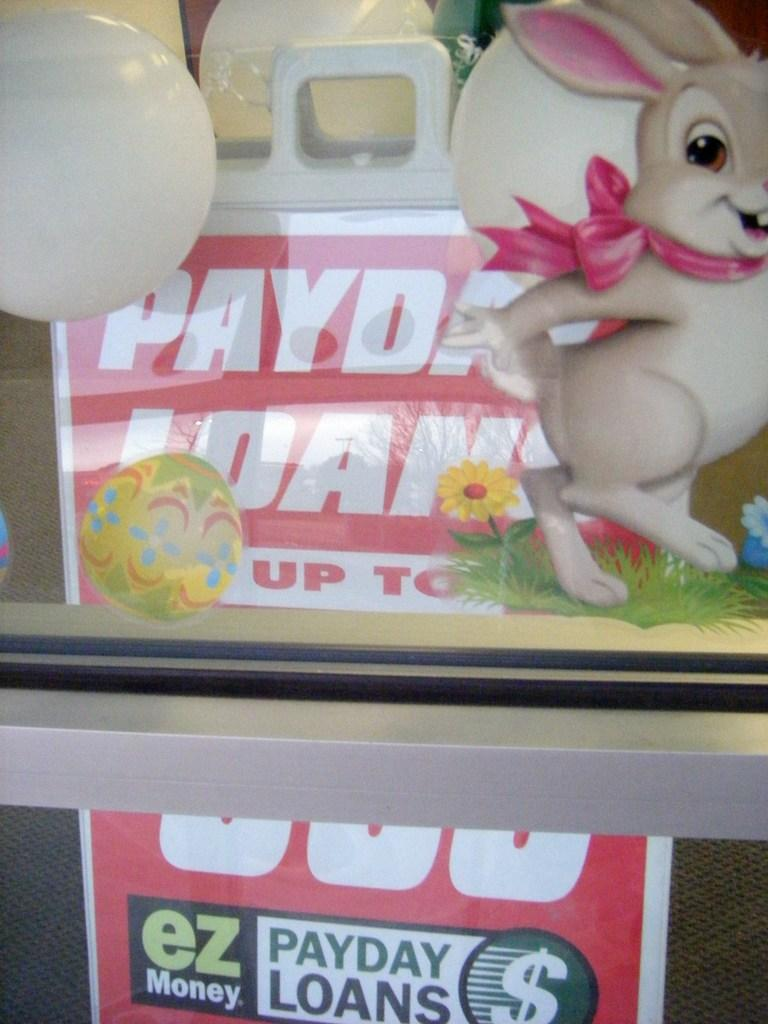<image>
Summarize the visual content of the image. A sign sits inside of a window that reads payday loans. 